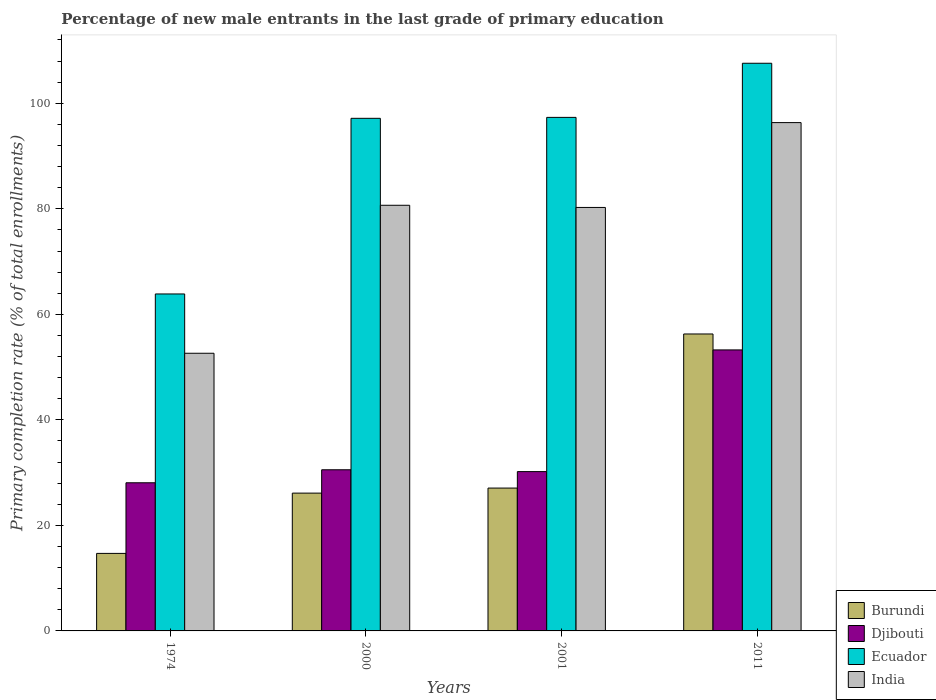How many different coloured bars are there?
Your response must be concise. 4. How many groups of bars are there?
Your answer should be compact. 4. Are the number of bars per tick equal to the number of legend labels?
Make the answer very short. Yes. Are the number of bars on each tick of the X-axis equal?
Give a very brief answer. Yes. How many bars are there on the 4th tick from the left?
Keep it short and to the point. 4. How many bars are there on the 2nd tick from the right?
Your answer should be very brief. 4. What is the label of the 1st group of bars from the left?
Provide a succinct answer. 1974. In how many cases, is the number of bars for a given year not equal to the number of legend labels?
Provide a succinct answer. 0. What is the percentage of new male entrants in Djibouti in 2000?
Make the answer very short. 30.54. Across all years, what is the maximum percentage of new male entrants in Ecuador?
Your answer should be very brief. 107.58. Across all years, what is the minimum percentage of new male entrants in Djibouti?
Offer a terse response. 28.08. In which year was the percentage of new male entrants in Ecuador minimum?
Keep it short and to the point. 1974. What is the total percentage of new male entrants in Djibouti in the graph?
Offer a very short reply. 142.07. What is the difference between the percentage of new male entrants in Djibouti in 2001 and that in 2011?
Keep it short and to the point. -23.06. What is the difference between the percentage of new male entrants in Ecuador in 2011 and the percentage of new male entrants in Burundi in 2000?
Provide a succinct answer. 81.47. What is the average percentage of new male entrants in Burundi per year?
Provide a succinct answer. 31.04. In the year 2001, what is the difference between the percentage of new male entrants in India and percentage of new male entrants in Ecuador?
Your answer should be compact. -17.07. What is the ratio of the percentage of new male entrants in Ecuador in 2001 to that in 2011?
Make the answer very short. 0.9. Is the difference between the percentage of new male entrants in India in 1974 and 2011 greater than the difference between the percentage of new male entrants in Ecuador in 1974 and 2011?
Give a very brief answer. Yes. What is the difference between the highest and the second highest percentage of new male entrants in Djibouti?
Make the answer very short. 22.71. What is the difference between the highest and the lowest percentage of new male entrants in Djibouti?
Provide a succinct answer. 25.18. Is the sum of the percentage of new male entrants in Burundi in 1974 and 2000 greater than the maximum percentage of new male entrants in India across all years?
Your response must be concise. No. Is it the case that in every year, the sum of the percentage of new male entrants in Djibouti and percentage of new male entrants in Ecuador is greater than the sum of percentage of new male entrants in Burundi and percentage of new male entrants in India?
Keep it short and to the point. No. What does the 2nd bar from the left in 1974 represents?
Provide a short and direct response. Djibouti. What does the 3rd bar from the right in 2000 represents?
Your answer should be very brief. Djibouti. How many years are there in the graph?
Make the answer very short. 4. How many legend labels are there?
Give a very brief answer. 4. What is the title of the graph?
Keep it short and to the point. Percentage of new male entrants in the last grade of primary education. Does "Greece" appear as one of the legend labels in the graph?
Make the answer very short. No. What is the label or title of the Y-axis?
Offer a terse response. Primary completion rate (% of total enrollments). What is the Primary completion rate (% of total enrollments) of Burundi in 1974?
Ensure brevity in your answer.  14.69. What is the Primary completion rate (% of total enrollments) of Djibouti in 1974?
Ensure brevity in your answer.  28.08. What is the Primary completion rate (% of total enrollments) of Ecuador in 1974?
Your answer should be very brief. 63.86. What is the Primary completion rate (% of total enrollments) in India in 1974?
Provide a succinct answer. 52.62. What is the Primary completion rate (% of total enrollments) in Burundi in 2000?
Offer a terse response. 26.12. What is the Primary completion rate (% of total enrollments) in Djibouti in 2000?
Your answer should be very brief. 30.54. What is the Primary completion rate (% of total enrollments) in Ecuador in 2000?
Keep it short and to the point. 97.15. What is the Primary completion rate (% of total enrollments) of India in 2000?
Your response must be concise. 80.67. What is the Primary completion rate (% of total enrollments) in Burundi in 2001?
Offer a terse response. 27.07. What is the Primary completion rate (% of total enrollments) of Djibouti in 2001?
Your answer should be very brief. 30.19. What is the Primary completion rate (% of total enrollments) in Ecuador in 2001?
Ensure brevity in your answer.  97.33. What is the Primary completion rate (% of total enrollments) in India in 2001?
Offer a terse response. 80.26. What is the Primary completion rate (% of total enrollments) in Burundi in 2011?
Provide a succinct answer. 56.28. What is the Primary completion rate (% of total enrollments) of Djibouti in 2011?
Provide a short and direct response. 53.26. What is the Primary completion rate (% of total enrollments) of Ecuador in 2011?
Your answer should be very brief. 107.58. What is the Primary completion rate (% of total enrollments) in India in 2011?
Offer a very short reply. 96.34. Across all years, what is the maximum Primary completion rate (% of total enrollments) in Burundi?
Provide a succinct answer. 56.28. Across all years, what is the maximum Primary completion rate (% of total enrollments) of Djibouti?
Provide a succinct answer. 53.26. Across all years, what is the maximum Primary completion rate (% of total enrollments) in Ecuador?
Ensure brevity in your answer.  107.58. Across all years, what is the maximum Primary completion rate (% of total enrollments) in India?
Your answer should be compact. 96.34. Across all years, what is the minimum Primary completion rate (% of total enrollments) of Burundi?
Your answer should be very brief. 14.69. Across all years, what is the minimum Primary completion rate (% of total enrollments) in Djibouti?
Your response must be concise. 28.08. Across all years, what is the minimum Primary completion rate (% of total enrollments) of Ecuador?
Your answer should be very brief. 63.86. Across all years, what is the minimum Primary completion rate (% of total enrollments) of India?
Give a very brief answer. 52.62. What is the total Primary completion rate (% of total enrollments) in Burundi in the graph?
Offer a terse response. 124.16. What is the total Primary completion rate (% of total enrollments) in Djibouti in the graph?
Provide a short and direct response. 142.07. What is the total Primary completion rate (% of total enrollments) in Ecuador in the graph?
Your answer should be very brief. 365.92. What is the total Primary completion rate (% of total enrollments) in India in the graph?
Provide a short and direct response. 309.88. What is the difference between the Primary completion rate (% of total enrollments) in Burundi in 1974 and that in 2000?
Give a very brief answer. -11.42. What is the difference between the Primary completion rate (% of total enrollments) of Djibouti in 1974 and that in 2000?
Ensure brevity in your answer.  -2.47. What is the difference between the Primary completion rate (% of total enrollments) in Ecuador in 1974 and that in 2000?
Keep it short and to the point. -33.29. What is the difference between the Primary completion rate (% of total enrollments) of India in 1974 and that in 2000?
Give a very brief answer. -28.05. What is the difference between the Primary completion rate (% of total enrollments) in Burundi in 1974 and that in 2001?
Keep it short and to the point. -12.38. What is the difference between the Primary completion rate (% of total enrollments) in Djibouti in 1974 and that in 2001?
Give a very brief answer. -2.12. What is the difference between the Primary completion rate (% of total enrollments) in Ecuador in 1974 and that in 2001?
Make the answer very short. -33.46. What is the difference between the Primary completion rate (% of total enrollments) of India in 1974 and that in 2001?
Ensure brevity in your answer.  -27.63. What is the difference between the Primary completion rate (% of total enrollments) in Burundi in 1974 and that in 2011?
Ensure brevity in your answer.  -41.58. What is the difference between the Primary completion rate (% of total enrollments) in Djibouti in 1974 and that in 2011?
Provide a succinct answer. -25.18. What is the difference between the Primary completion rate (% of total enrollments) in Ecuador in 1974 and that in 2011?
Offer a terse response. -43.72. What is the difference between the Primary completion rate (% of total enrollments) in India in 1974 and that in 2011?
Keep it short and to the point. -43.71. What is the difference between the Primary completion rate (% of total enrollments) in Burundi in 2000 and that in 2001?
Your answer should be compact. -0.96. What is the difference between the Primary completion rate (% of total enrollments) of Djibouti in 2000 and that in 2001?
Offer a terse response. 0.35. What is the difference between the Primary completion rate (% of total enrollments) of Ecuador in 2000 and that in 2001?
Provide a short and direct response. -0.18. What is the difference between the Primary completion rate (% of total enrollments) in India in 2000 and that in 2001?
Keep it short and to the point. 0.41. What is the difference between the Primary completion rate (% of total enrollments) in Burundi in 2000 and that in 2011?
Ensure brevity in your answer.  -30.16. What is the difference between the Primary completion rate (% of total enrollments) in Djibouti in 2000 and that in 2011?
Offer a very short reply. -22.71. What is the difference between the Primary completion rate (% of total enrollments) in Ecuador in 2000 and that in 2011?
Keep it short and to the point. -10.44. What is the difference between the Primary completion rate (% of total enrollments) in India in 2000 and that in 2011?
Make the answer very short. -15.67. What is the difference between the Primary completion rate (% of total enrollments) of Burundi in 2001 and that in 2011?
Provide a succinct answer. -29.2. What is the difference between the Primary completion rate (% of total enrollments) of Djibouti in 2001 and that in 2011?
Offer a very short reply. -23.06. What is the difference between the Primary completion rate (% of total enrollments) of Ecuador in 2001 and that in 2011?
Your answer should be compact. -10.26. What is the difference between the Primary completion rate (% of total enrollments) of India in 2001 and that in 2011?
Provide a succinct answer. -16.08. What is the difference between the Primary completion rate (% of total enrollments) in Burundi in 1974 and the Primary completion rate (% of total enrollments) in Djibouti in 2000?
Give a very brief answer. -15.85. What is the difference between the Primary completion rate (% of total enrollments) of Burundi in 1974 and the Primary completion rate (% of total enrollments) of Ecuador in 2000?
Your answer should be compact. -82.46. What is the difference between the Primary completion rate (% of total enrollments) of Burundi in 1974 and the Primary completion rate (% of total enrollments) of India in 2000?
Offer a very short reply. -65.98. What is the difference between the Primary completion rate (% of total enrollments) of Djibouti in 1974 and the Primary completion rate (% of total enrollments) of Ecuador in 2000?
Your answer should be very brief. -69.07. What is the difference between the Primary completion rate (% of total enrollments) of Djibouti in 1974 and the Primary completion rate (% of total enrollments) of India in 2000?
Your answer should be very brief. -52.59. What is the difference between the Primary completion rate (% of total enrollments) of Ecuador in 1974 and the Primary completion rate (% of total enrollments) of India in 2000?
Your response must be concise. -16.81. What is the difference between the Primary completion rate (% of total enrollments) in Burundi in 1974 and the Primary completion rate (% of total enrollments) in Djibouti in 2001?
Offer a very short reply. -15.5. What is the difference between the Primary completion rate (% of total enrollments) of Burundi in 1974 and the Primary completion rate (% of total enrollments) of Ecuador in 2001?
Give a very brief answer. -82.63. What is the difference between the Primary completion rate (% of total enrollments) of Burundi in 1974 and the Primary completion rate (% of total enrollments) of India in 2001?
Offer a terse response. -65.56. What is the difference between the Primary completion rate (% of total enrollments) in Djibouti in 1974 and the Primary completion rate (% of total enrollments) in Ecuador in 2001?
Your response must be concise. -69.25. What is the difference between the Primary completion rate (% of total enrollments) in Djibouti in 1974 and the Primary completion rate (% of total enrollments) in India in 2001?
Your response must be concise. -52.18. What is the difference between the Primary completion rate (% of total enrollments) of Ecuador in 1974 and the Primary completion rate (% of total enrollments) of India in 2001?
Your answer should be compact. -16.39. What is the difference between the Primary completion rate (% of total enrollments) of Burundi in 1974 and the Primary completion rate (% of total enrollments) of Djibouti in 2011?
Your answer should be compact. -38.56. What is the difference between the Primary completion rate (% of total enrollments) of Burundi in 1974 and the Primary completion rate (% of total enrollments) of Ecuador in 2011?
Give a very brief answer. -92.89. What is the difference between the Primary completion rate (% of total enrollments) of Burundi in 1974 and the Primary completion rate (% of total enrollments) of India in 2011?
Your answer should be very brief. -81.64. What is the difference between the Primary completion rate (% of total enrollments) of Djibouti in 1974 and the Primary completion rate (% of total enrollments) of Ecuador in 2011?
Give a very brief answer. -79.51. What is the difference between the Primary completion rate (% of total enrollments) in Djibouti in 1974 and the Primary completion rate (% of total enrollments) in India in 2011?
Keep it short and to the point. -68.26. What is the difference between the Primary completion rate (% of total enrollments) in Ecuador in 1974 and the Primary completion rate (% of total enrollments) in India in 2011?
Keep it short and to the point. -32.47. What is the difference between the Primary completion rate (% of total enrollments) in Burundi in 2000 and the Primary completion rate (% of total enrollments) in Djibouti in 2001?
Give a very brief answer. -4.08. What is the difference between the Primary completion rate (% of total enrollments) of Burundi in 2000 and the Primary completion rate (% of total enrollments) of Ecuador in 2001?
Provide a short and direct response. -71.21. What is the difference between the Primary completion rate (% of total enrollments) in Burundi in 2000 and the Primary completion rate (% of total enrollments) in India in 2001?
Provide a short and direct response. -54.14. What is the difference between the Primary completion rate (% of total enrollments) in Djibouti in 2000 and the Primary completion rate (% of total enrollments) in Ecuador in 2001?
Offer a very short reply. -66.78. What is the difference between the Primary completion rate (% of total enrollments) in Djibouti in 2000 and the Primary completion rate (% of total enrollments) in India in 2001?
Keep it short and to the point. -49.71. What is the difference between the Primary completion rate (% of total enrollments) of Ecuador in 2000 and the Primary completion rate (% of total enrollments) of India in 2001?
Ensure brevity in your answer.  16.89. What is the difference between the Primary completion rate (% of total enrollments) in Burundi in 2000 and the Primary completion rate (% of total enrollments) in Djibouti in 2011?
Your answer should be very brief. -27.14. What is the difference between the Primary completion rate (% of total enrollments) in Burundi in 2000 and the Primary completion rate (% of total enrollments) in Ecuador in 2011?
Ensure brevity in your answer.  -81.47. What is the difference between the Primary completion rate (% of total enrollments) of Burundi in 2000 and the Primary completion rate (% of total enrollments) of India in 2011?
Provide a short and direct response. -70.22. What is the difference between the Primary completion rate (% of total enrollments) of Djibouti in 2000 and the Primary completion rate (% of total enrollments) of Ecuador in 2011?
Make the answer very short. -77.04. What is the difference between the Primary completion rate (% of total enrollments) of Djibouti in 2000 and the Primary completion rate (% of total enrollments) of India in 2011?
Your answer should be very brief. -65.79. What is the difference between the Primary completion rate (% of total enrollments) in Ecuador in 2000 and the Primary completion rate (% of total enrollments) in India in 2011?
Offer a very short reply. 0.81. What is the difference between the Primary completion rate (% of total enrollments) of Burundi in 2001 and the Primary completion rate (% of total enrollments) of Djibouti in 2011?
Provide a short and direct response. -26.18. What is the difference between the Primary completion rate (% of total enrollments) of Burundi in 2001 and the Primary completion rate (% of total enrollments) of Ecuador in 2011?
Your answer should be very brief. -80.51. What is the difference between the Primary completion rate (% of total enrollments) in Burundi in 2001 and the Primary completion rate (% of total enrollments) in India in 2011?
Your answer should be very brief. -69.26. What is the difference between the Primary completion rate (% of total enrollments) of Djibouti in 2001 and the Primary completion rate (% of total enrollments) of Ecuador in 2011?
Provide a short and direct response. -77.39. What is the difference between the Primary completion rate (% of total enrollments) of Djibouti in 2001 and the Primary completion rate (% of total enrollments) of India in 2011?
Provide a short and direct response. -66.14. What is the difference between the Primary completion rate (% of total enrollments) in Ecuador in 2001 and the Primary completion rate (% of total enrollments) in India in 2011?
Give a very brief answer. 0.99. What is the average Primary completion rate (% of total enrollments) of Burundi per year?
Offer a very short reply. 31.04. What is the average Primary completion rate (% of total enrollments) in Djibouti per year?
Your answer should be compact. 35.52. What is the average Primary completion rate (% of total enrollments) in Ecuador per year?
Ensure brevity in your answer.  91.48. What is the average Primary completion rate (% of total enrollments) of India per year?
Your answer should be compact. 77.47. In the year 1974, what is the difference between the Primary completion rate (% of total enrollments) in Burundi and Primary completion rate (% of total enrollments) in Djibouti?
Keep it short and to the point. -13.38. In the year 1974, what is the difference between the Primary completion rate (% of total enrollments) of Burundi and Primary completion rate (% of total enrollments) of Ecuador?
Give a very brief answer. -49.17. In the year 1974, what is the difference between the Primary completion rate (% of total enrollments) of Burundi and Primary completion rate (% of total enrollments) of India?
Provide a short and direct response. -37.93. In the year 1974, what is the difference between the Primary completion rate (% of total enrollments) of Djibouti and Primary completion rate (% of total enrollments) of Ecuador?
Offer a very short reply. -35.78. In the year 1974, what is the difference between the Primary completion rate (% of total enrollments) in Djibouti and Primary completion rate (% of total enrollments) in India?
Your response must be concise. -24.55. In the year 1974, what is the difference between the Primary completion rate (% of total enrollments) in Ecuador and Primary completion rate (% of total enrollments) in India?
Offer a terse response. 11.24. In the year 2000, what is the difference between the Primary completion rate (% of total enrollments) of Burundi and Primary completion rate (% of total enrollments) of Djibouti?
Offer a terse response. -4.43. In the year 2000, what is the difference between the Primary completion rate (% of total enrollments) of Burundi and Primary completion rate (% of total enrollments) of Ecuador?
Your answer should be compact. -71.03. In the year 2000, what is the difference between the Primary completion rate (% of total enrollments) in Burundi and Primary completion rate (% of total enrollments) in India?
Ensure brevity in your answer.  -54.55. In the year 2000, what is the difference between the Primary completion rate (% of total enrollments) of Djibouti and Primary completion rate (% of total enrollments) of Ecuador?
Ensure brevity in your answer.  -66.61. In the year 2000, what is the difference between the Primary completion rate (% of total enrollments) of Djibouti and Primary completion rate (% of total enrollments) of India?
Make the answer very short. -50.13. In the year 2000, what is the difference between the Primary completion rate (% of total enrollments) of Ecuador and Primary completion rate (% of total enrollments) of India?
Your answer should be compact. 16.48. In the year 2001, what is the difference between the Primary completion rate (% of total enrollments) in Burundi and Primary completion rate (% of total enrollments) in Djibouti?
Your answer should be compact. -3.12. In the year 2001, what is the difference between the Primary completion rate (% of total enrollments) of Burundi and Primary completion rate (% of total enrollments) of Ecuador?
Offer a terse response. -70.25. In the year 2001, what is the difference between the Primary completion rate (% of total enrollments) of Burundi and Primary completion rate (% of total enrollments) of India?
Provide a short and direct response. -53.18. In the year 2001, what is the difference between the Primary completion rate (% of total enrollments) of Djibouti and Primary completion rate (% of total enrollments) of Ecuador?
Provide a short and direct response. -67.13. In the year 2001, what is the difference between the Primary completion rate (% of total enrollments) in Djibouti and Primary completion rate (% of total enrollments) in India?
Keep it short and to the point. -50.06. In the year 2001, what is the difference between the Primary completion rate (% of total enrollments) of Ecuador and Primary completion rate (% of total enrollments) of India?
Provide a short and direct response. 17.07. In the year 2011, what is the difference between the Primary completion rate (% of total enrollments) in Burundi and Primary completion rate (% of total enrollments) in Djibouti?
Offer a very short reply. 3.02. In the year 2011, what is the difference between the Primary completion rate (% of total enrollments) in Burundi and Primary completion rate (% of total enrollments) in Ecuador?
Make the answer very short. -51.31. In the year 2011, what is the difference between the Primary completion rate (% of total enrollments) of Burundi and Primary completion rate (% of total enrollments) of India?
Your answer should be compact. -40.06. In the year 2011, what is the difference between the Primary completion rate (% of total enrollments) in Djibouti and Primary completion rate (% of total enrollments) in Ecuador?
Provide a short and direct response. -54.33. In the year 2011, what is the difference between the Primary completion rate (% of total enrollments) of Djibouti and Primary completion rate (% of total enrollments) of India?
Your answer should be compact. -43.08. In the year 2011, what is the difference between the Primary completion rate (% of total enrollments) of Ecuador and Primary completion rate (% of total enrollments) of India?
Give a very brief answer. 11.25. What is the ratio of the Primary completion rate (% of total enrollments) in Burundi in 1974 to that in 2000?
Ensure brevity in your answer.  0.56. What is the ratio of the Primary completion rate (% of total enrollments) of Djibouti in 1974 to that in 2000?
Offer a very short reply. 0.92. What is the ratio of the Primary completion rate (% of total enrollments) of Ecuador in 1974 to that in 2000?
Provide a short and direct response. 0.66. What is the ratio of the Primary completion rate (% of total enrollments) in India in 1974 to that in 2000?
Give a very brief answer. 0.65. What is the ratio of the Primary completion rate (% of total enrollments) of Burundi in 1974 to that in 2001?
Ensure brevity in your answer.  0.54. What is the ratio of the Primary completion rate (% of total enrollments) of Djibouti in 1974 to that in 2001?
Provide a short and direct response. 0.93. What is the ratio of the Primary completion rate (% of total enrollments) in Ecuador in 1974 to that in 2001?
Provide a short and direct response. 0.66. What is the ratio of the Primary completion rate (% of total enrollments) in India in 1974 to that in 2001?
Your answer should be very brief. 0.66. What is the ratio of the Primary completion rate (% of total enrollments) of Burundi in 1974 to that in 2011?
Provide a succinct answer. 0.26. What is the ratio of the Primary completion rate (% of total enrollments) in Djibouti in 1974 to that in 2011?
Keep it short and to the point. 0.53. What is the ratio of the Primary completion rate (% of total enrollments) in Ecuador in 1974 to that in 2011?
Provide a succinct answer. 0.59. What is the ratio of the Primary completion rate (% of total enrollments) of India in 1974 to that in 2011?
Your response must be concise. 0.55. What is the ratio of the Primary completion rate (% of total enrollments) of Burundi in 2000 to that in 2001?
Offer a terse response. 0.96. What is the ratio of the Primary completion rate (% of total enrollments) in Djibouti in 2000 to that in 2001?
Provide a succinct answer. 1.01. What is the ratio of the Primary completion rate (% of total enrollments) in India in 2000 to that in 2001?
Your response must be concise. 1.01. What is the ratio of the Primary completion rate (% of total enrollments) of Burundi in 2000 to that in 2011?
Your response must be concise. 0.46. What is the ratio of the Primary completion rate (% of total enrollments) of Djibouti in 2000 to that in 2011?
Offer a very short reply. 0.57. What is the ratio of the Primary completion rate (% of total enrollments) of Ecuador in 2000 to that in 2011?
Your answer should be compact. 0.9. What is the ratio of the Primary completion rate (% of total enrollments) in India in 2000 to that in 2011?
Give a very brief answer. 0.84. What is the ratio of the Primary completion rate (% of total enrollments) of Burundi in 2001 to that in 2011?
Provide a short and direct response. 0.48. What is the ratio of the Primary completion rate (% of total enrollments) in Djibouti in 2001 to that in 2011?
Ensure brevity in your answer.  0.57. What is the ratio of the Primary completion rate (% of total enrollments) in Ecuador in 2001 to that in 2011?
Offer a very short reply. 0.9. What is the ratio of the Primary completion rate (% of total enrollments) of India in 2001 to that in 2011?
Your answer should be very brief. 0.83. What is the difference between the highest and the second highest Primary completion rate (% of total enrollments) in Burundi?
Your response must be concise. 29.2. What is the difference between the highest and the second highest Primary completion rate (% of total enrollments) in Djibouti?
Offer a terse response. 22.71. What is the difference between the highest and the second highest Primary completion rate (% of total enrollments) in Ecuador?
Offer a terse response. 10.26. What is the difference between the highest and the second highest Primary completion rate (% of total enrollments) in India?
Your answer should be very brief. 15.67. What is the difference between the highest and the lowest Primary completion rate (% of total enrollments) of Burundi?
Ensure brevity in your answer.  41.58. What is the difference between the highest and the lowest Primary completion rate (% of total enrollments) of Djibouti?
Offer a terse response. 25.18. What is the difference between the highest and the lowest Primary completion rate (% of total enrollments) of Ecuador?
Keep it short and to the point. 43.72. What is the difference between the highest and the lowest Primary completion rate (% of total enrollments) of India?
Your answer should be compact. 43.71. 